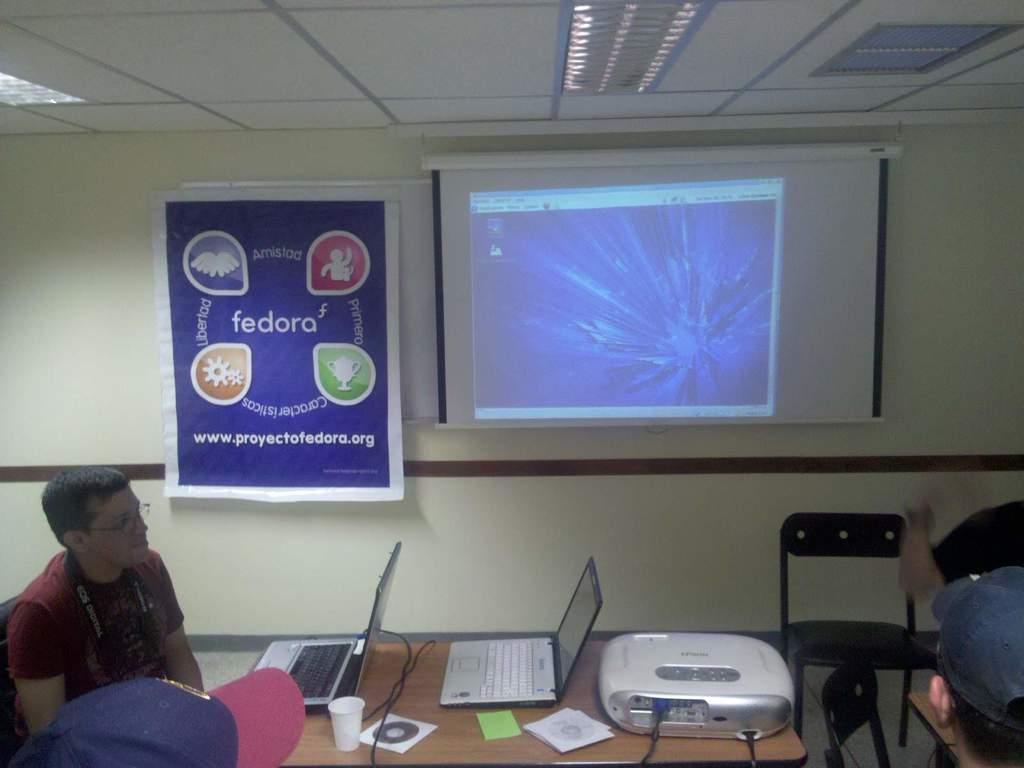In one or two sentences, can you explain what this image depicts? In this image there are three person sitting on the chair. In front of the man there is table,on table there is a laptop,cpu,CD and a projector machine. At the background we can see a banner and a screen on the wall. 